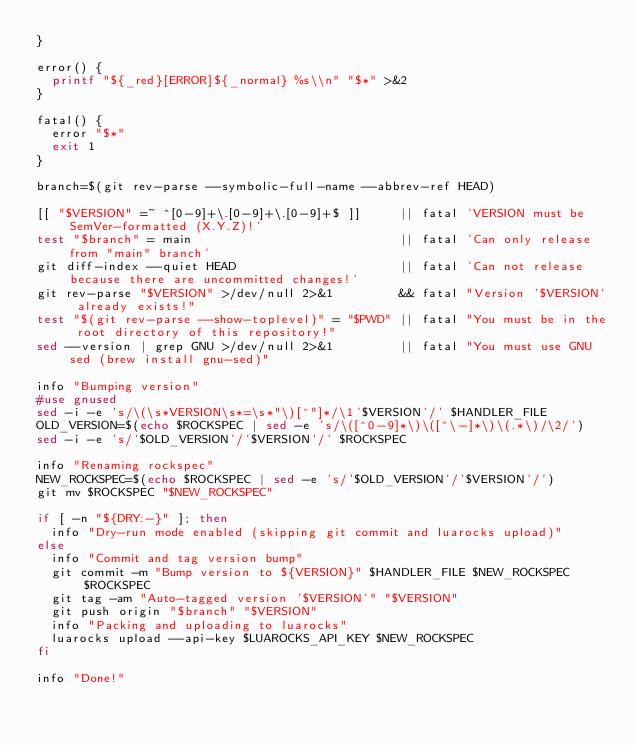<code> <loc_0><loc_0><loc_500><loc_500><_Bash_>}

error() {
  printf "${_red}[ERROR]${_normal} %s\\n" "$*" >&2
}

fatal() {
  error "$*"
  exit 1
}

branch=$(git rev-parse --symbolic-full-name --abbrev-ref HEAD)

[[ "$VERSION" =~ ^[0-9]+\.[0-9]+\.[0-9]+$ ]]     || fatal 'VERSION must be SemVer-formatted (X.Y.Z)!'
test "$branch" = main                            || fatal 'Can only release from "main" branch'
git diff-index --quiet HEAD                      || fatal 'Can not release because there are uncommitted changes!'
git rev-parse "$VERSION" >/dev/null 2>&1         && fatal "Version '$VERSION' already exists!"
test "$(git rev-parse --show-toplevel)" = "$PWD" || fatal "You must be in the root directory of this repository!"
sed --version | grep GNU >/dev/null 2>&1         || fatal "You must use GNU sed (brew install gnu-sed)"

info "Bumping version"
#use gnused
sed -i -e 's/\(\s*VERSION\s*=\s*"\)[^"]*/\1'$VERSION'/' $HANDLER_FILE
OLD_VERSION=$(echo $ROCKSPEC | sed -e 's/\([^0-9]*\)\([^\-]*\)\(.*\)/\2/')
sed -i -e 's/'$OLD_VERSION'/'$VERSION'/' $ROCKSPEC

info "Renaming rockspec"
NEW_ROCKSPEC=$(echo $ROCKSPEC | sed -e 's/'$OLD_VERSION'/'$VERSION'/')
git mv $ROCKSPEC "$NEW_ROCKSPEC"

if [ -n "${DRY:-}" ]; then
  info "Dry-run mode enabled (skipping git commit and luarocks upload)"
else
  info "Commit and tag version bump"
  git commit -m "Bump version to ${VERSION}" $HANDLER_FILE $NEW_ROCKSPEC $ROCKSPEC
  git tag -am "Auto-tagged version '$VERSION'" "$VERSION"
  git push origin "$branch" "$VERSION"
  info "Packing and uploading to luarocks"
  luarocks upload --api-key $LUAROCKS_API_KEY $NEW_ROCKSPEC
fi

info "Done!"
</code> 